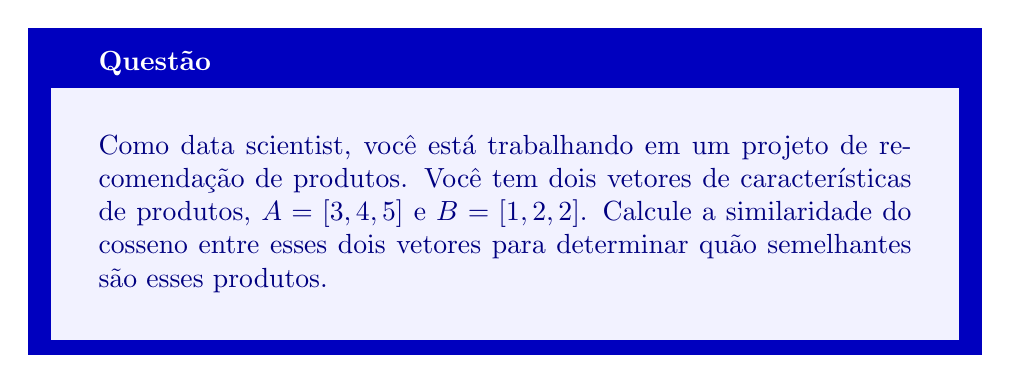Help me with this question. Para calcular a similaridade do cosseno entre dois vetores, seguimos os seguintes passos:

1. Calculamos o produto escalar dos vetores:
   $A \cdot B = (3 \times 1) + (4 \times 2) + (5 \times 2) = 3 + 8 + 10 = 21$

2. Calculamos a magnitude (norma) de cada vetor:
   $\|A\| = \sqrt{3^2 + 4^2 + 5^2} = \sqrt{9 + 16 + 25} = \sqrt{50}$
   $\|B\| = \sqrt{1^2 + 2^2 + 2^2} = \sqrt{1 + 4 + 4} = \sqrt{9} = 3$

3. Aplicamos a fórmula da similaridade do cosseno:
   $$\text{similaridade do cosseno} = \frac{A \cdot B}{\|A\| \times \|B\|}$$

4. Substituímos os valores calculados:
   $$\text{similaridade do cosseno} = \frac{21}{\sqrt{50} \times 3}$$

5. Simplificamos:
   $$\text{similaridade do cosseno} = \frac{21}{3\sqrt{50}} = \frac{7}{\sqrt{50}}$$

6. Para obter um valor decimal, podemos calcular:
   $$\frac{7}{\sqrt{50}} \approx 0.9899$$

A similaridade do cosseno varia de -1 a 1, onde 1 indica vetores perfeitamente alinhados, 0 indica ortogonalidade, e -1 indica vetores opostos. Um valor próximo a 1, como obtido aqui, indica alta similaridade entre os produtos.
Answer: A similaridade do cosseno entre os vetores $A$ e $B$ é $\frac{7}{\sqrt{50}}$ ou aproximadamente 0.9899. 